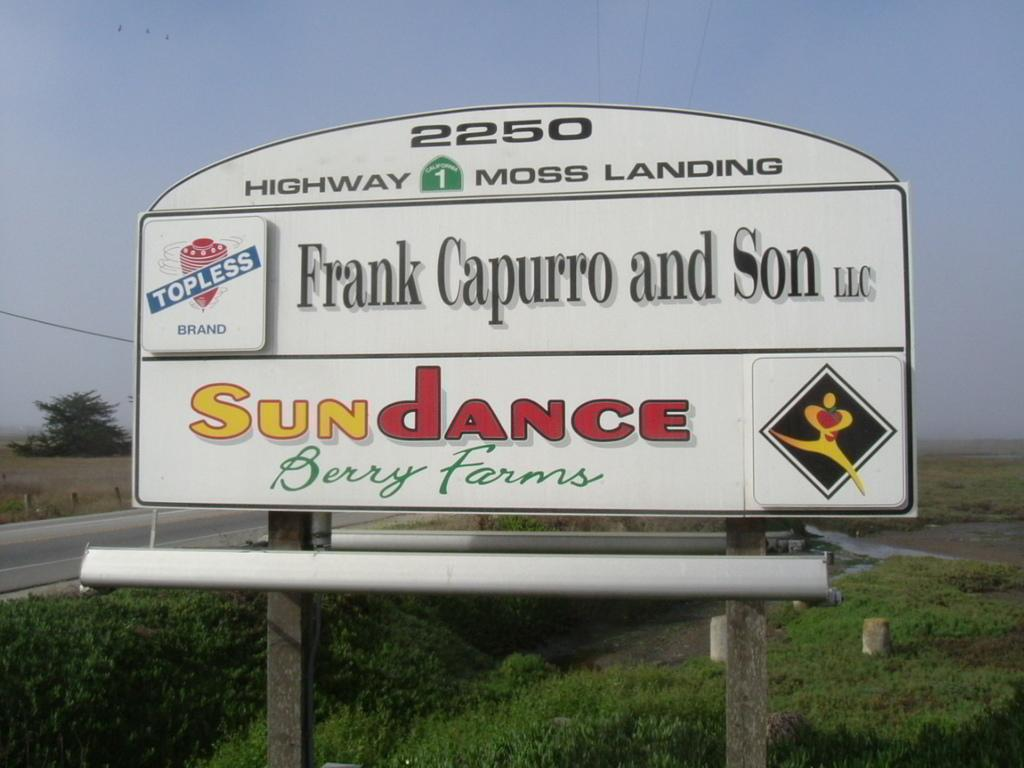<image>
Create a compact narrative representing the image presented. Road sign for HIghway 1 going to Moss Landing. 